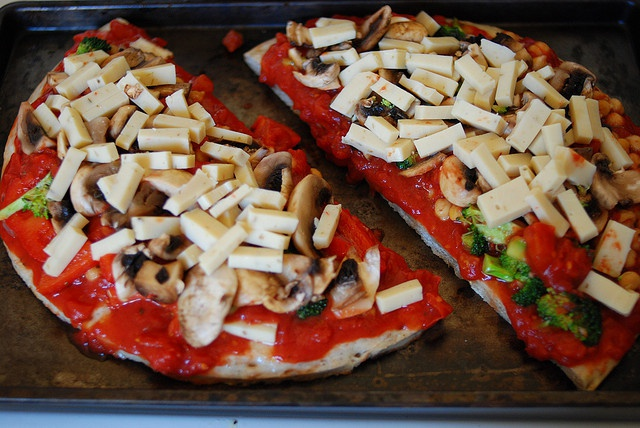Describe the objects in this image and their specific colors. I can see pizza in darkgray, brown, maroon, and tan tones, pizza in darkgray, maroon, black, and tan tones, broccoli in darkgray, black, olive, maroon, and darkgreen tones, broccoli in darkgray, olive, and black tones, and broccoli in darkgray, black, darkgreen, and green tones in this image. 